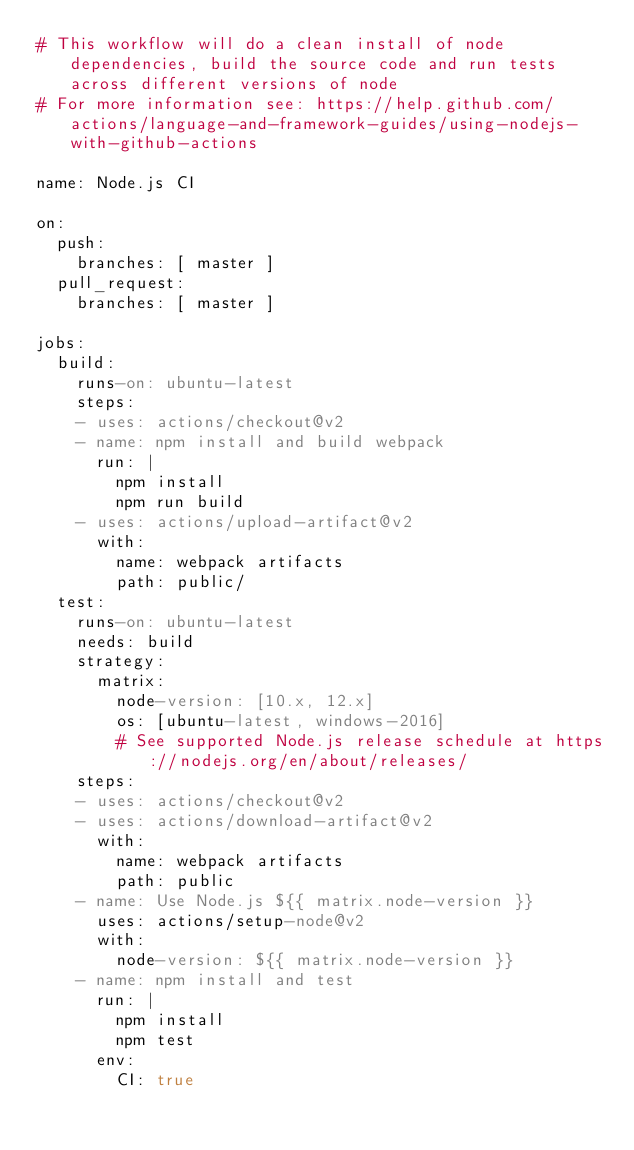<code> <loc_0><loc_0><loc_500><loc_500><_YAML_># This workflow will do a clean install of node dependencies, build the source code and run tests across different versions of node
# For more information see: https://help.github.com/actions/language-and-framework-guides/using-nodejs-with-github-actions

name: Node.js CI

on:
  push:
    branches: [ master ]
  pull_request:
    branches: [ master ]

jobs:
  build:
    runs-on: ubuntu-latest
    steps: 
    - uses: actions/checkout@v2
    - name: npm install and build webpack
      run: |
        npm install
        npm run build
    - uses: actions/upload-artifact@v2
      with:
        name: webpack artifacts
        path: public/
  test:
    runs-on: ubuntu-latest
    needs: build  
    strategy:
      matrix:
        node-version: [10.x, 12.x]
        os: [ubuntu-latest, windows-2016]
        # See supported Node.js release schedule at https://nodejs.org/en/about/releases/  
    steps:
    - uses: actions/checkout@v2
    - uses: actions/download-artifact@v2
      with:
        name: webpack artifacts
        path: public
    - name: Use Node.js ${{ matrix.node-version }}
      uses: actions/setup-node@v2
      with:
        node-version: ${{ matrix.node-version }}
    - name: npm install and test
      run: |
        npm install
        npm test
      env:
        CI: true
</code> 